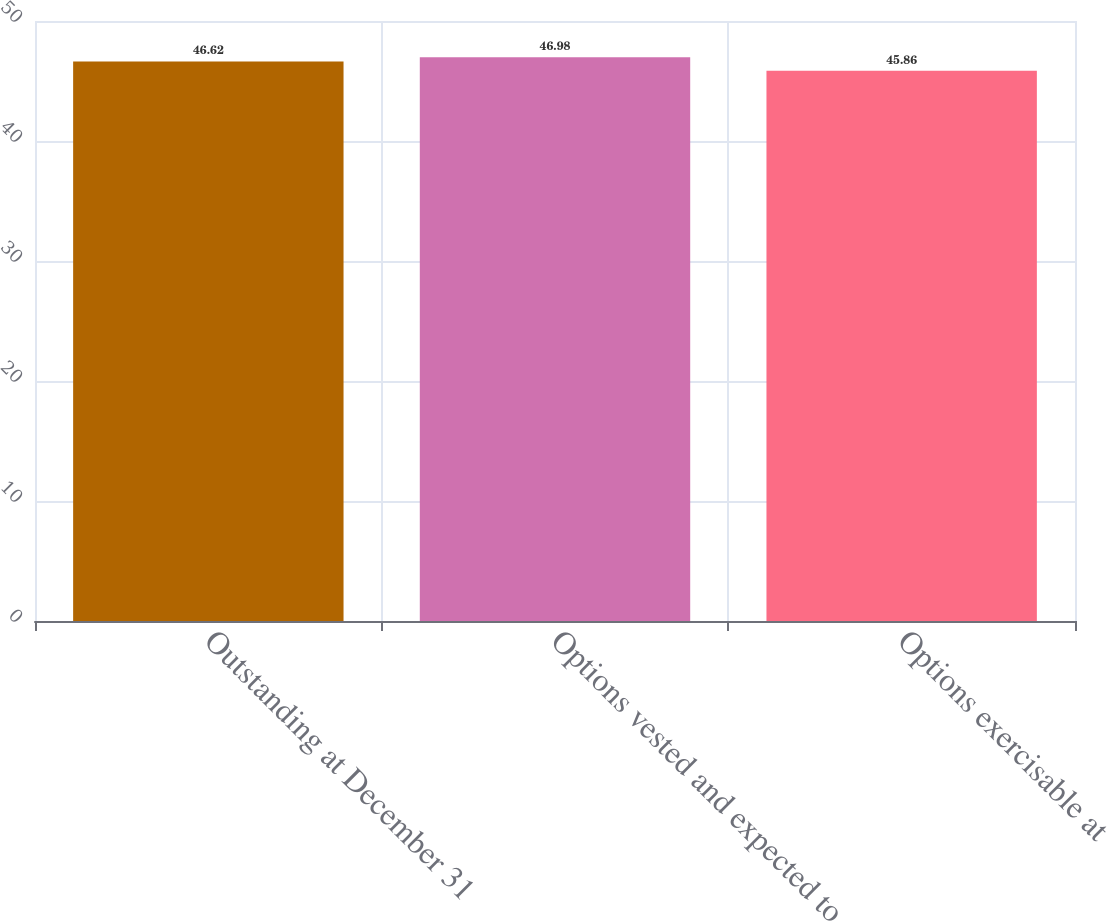<chart> <loc_0><loc_0><loc_500><loc_500><bar_chart><fcel>Outstanding at December 31<fcel>Options vested and expected to<fcel>Options exercisable at<nl><fcel>46.62<fcel>46.98<fcel>45.86<nl></chart> 